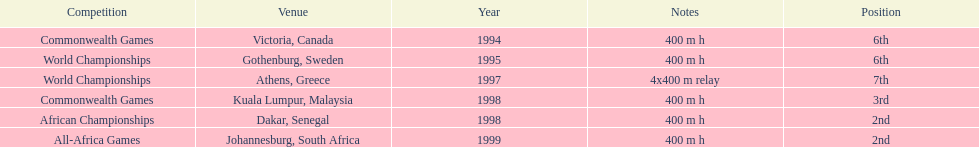Other than 1999, what year did ken harnden win second place? 1998. 